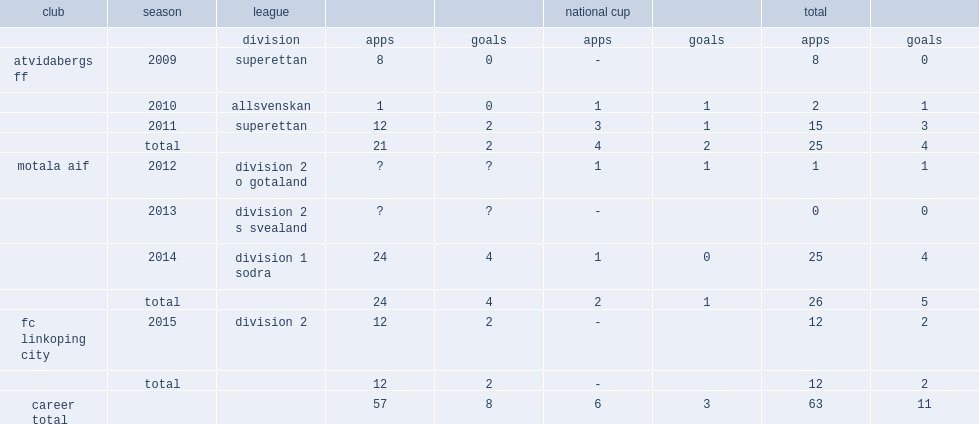Which league did daniel sward play with atvidabergs ff in 2009? Superettan. 